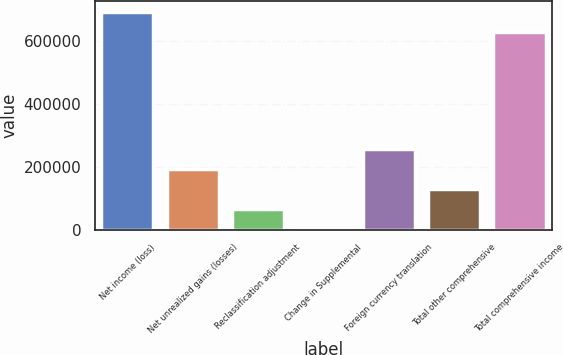Convert chart. <chart><loc_0><loc_0><loc_500><loc_500><bar_chart><fcel>Net income (loss)<fcel>Net unrealized gains (losses)<fcel>Reclassification adjustment<fcel>Change in Supplemental<fcel>Foreign currency translation<fcel>Total other comprehensive<fcel>Total comprehensive income<nl><fcel>692628<fcel>192380<fcel>64273.4<fcel>220<fcel>256434<fcel>128327<fcel>628575<nl></chart> 